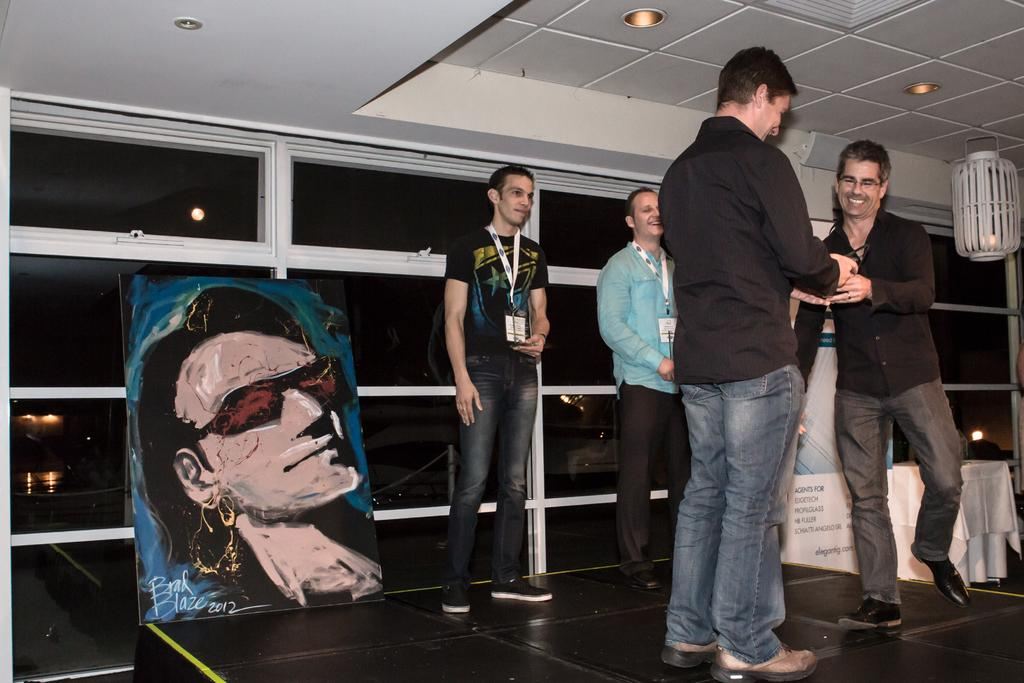How many people are in the image? There are four men in the image. Where are the men located in the image? The men are standing on a stage. What expressions do the men have in the image? The men are smiling. What can be seen hanging on the wall in the image? There is a painting in the image. What type of lighting is present in the image? There are lights in the image. What decorative elements are present in the image? There are banners in the image. How would you describe the background of the image? The background of the image is dark. What type of bottle can be seen on the stage in the image? There is no bottle present on the stage in the image. What material is the steel used for in the image? There is no steel present in the image. 